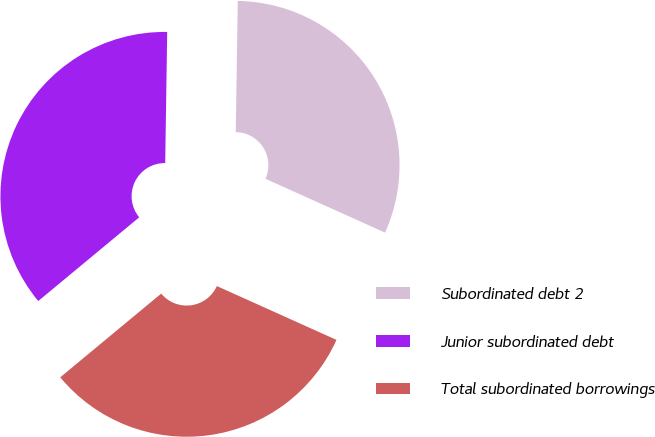Convert chart to OTSL. <chart><loc_0><loc_0><loc_500><loc_500><pie_chart><fcel>Subordinated debt 2<fcel>Junior subordinated debt<fcel>Total subordinated borrowings<nl><fcel>31.49%<fcel>36.26%<fcel>32.25%<nl></chart> 